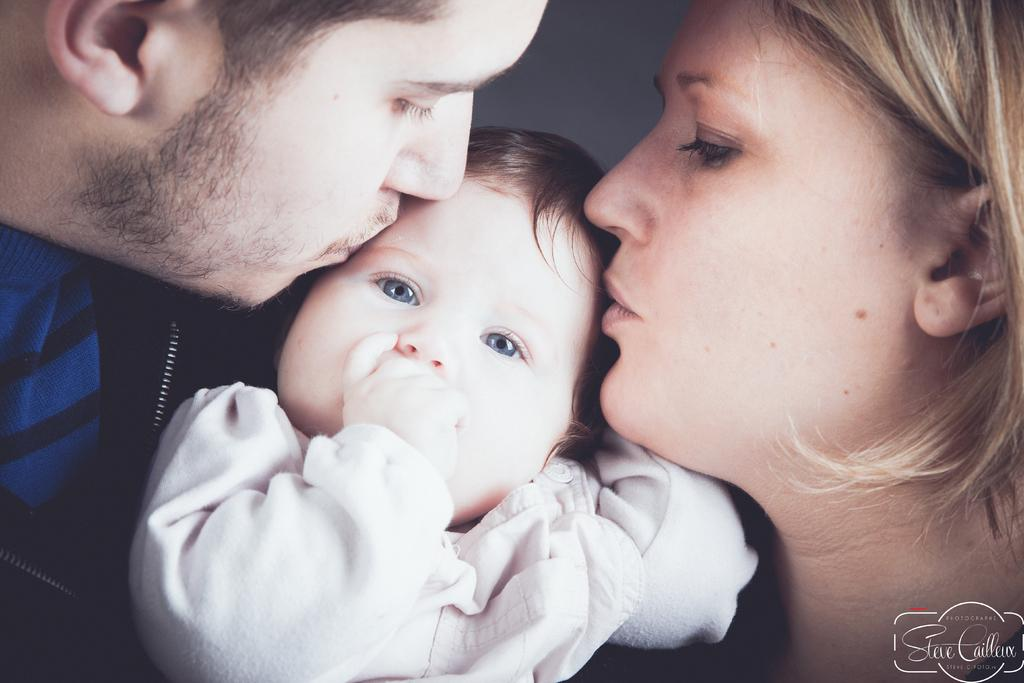Who is present in the image? There is a man and a woman in the image. What are the man and woman doing in the image? The man and woman are kissing a baby together. What is the color of the background in the image? The background of the image is white. Is there any text or logo visible in the image? Yes, there is a watermark in the bottom right corner of the image. What type of boot is the man wearing in the image? There is no boot visible in the image; the man is not wearing any footwear. Can you see the brother of the baby in the image? There is no mention of a brother in the image, and no other individuals are present besides the man, woman, and baby. 